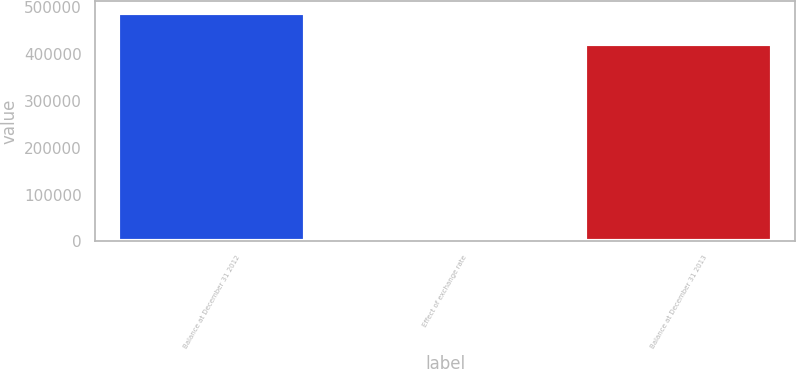Convert chart. <chart><loc_0><loc_0><loc_500><loc_500><bar_chart><fcel>Balance at December 31 2012<fcel>Effect of exchange rate<fcel>Balance at December 31 2013<nl><fcel>488206<fcel>1844<fcel>421282<nl></chart> 